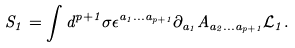Convert formula to latex. <formula><loc_0><loc_0><loc_500><loc_500>S _ { 1 } = \int d ^ { p + 1 } \sigma \epsilon ^ { a _ { 1 } \dots a _ { p + 1 } } \partial _ { a _ { 1 } } A _ { a _ { 2 } \dots a _ { p + 1 } } { \mathcal { L } } _ { 1 } .</formula> 